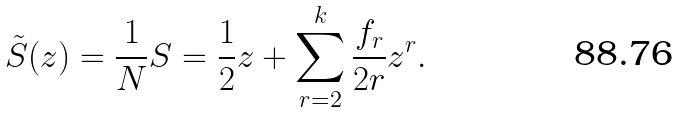Convert formula to latex. <formula><loc_0><loc_0><loc_500><loc_500>\tilde { S } ( z ) = \frac { 1 } { N } S = \frac { 1 } { 2 } z + \sum ^ { k } _ { r = 2 } \frac { f _ { r } } { 2 r } z ^ { r } .</formula> 